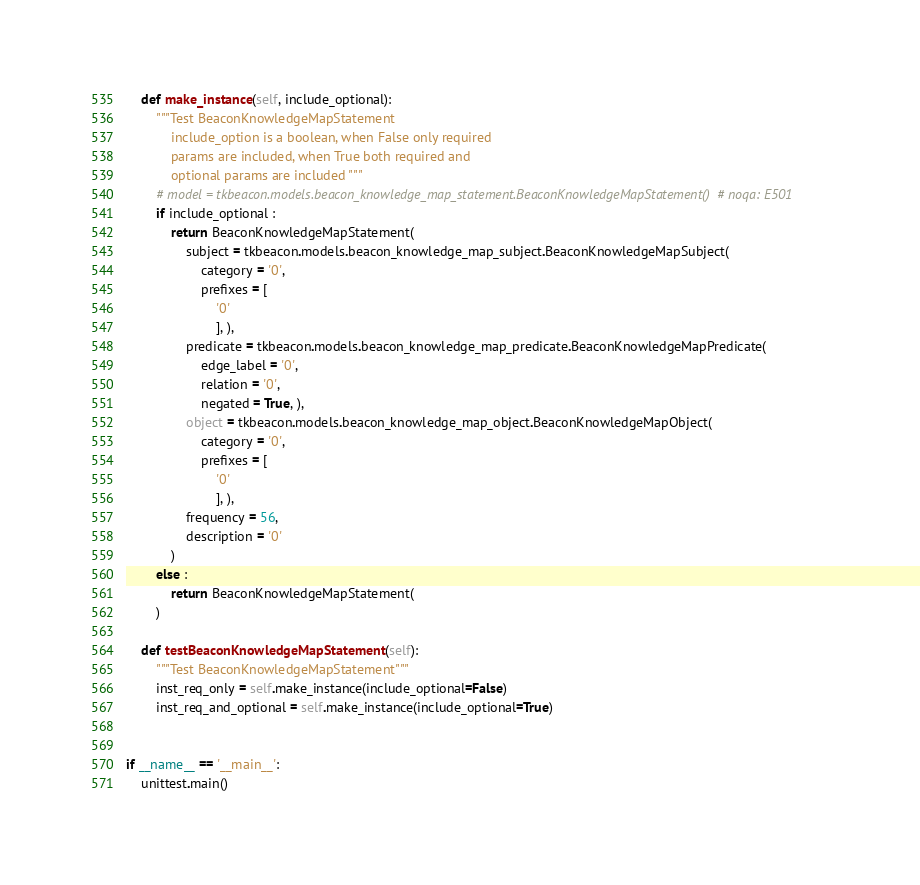<code> <loc_0><loc_0><loc_500><loc_500><_Python_>    def make_instance(self, include_optional):
        """Test BeaconKnowledgeMapStatement
            include_option is a boolean, when False only required
            params are included, when True both required and
            optional params are included """
        # model = tkbeacon.models.beacon_knowledge_map_statement.BeaconKnowledgeMapStatement()  # noqa: E501
        if include_optional :
            return BeaconKnowledgeMapStatement(
                subject = tkbeacon.models.beacon_knowledge_map_subject.BeaconKnowledgeMapSubject(
                    category = '0', 
                    prefixes = [
                        '0'
                        ], ), 
                predicate = tkbeacon.models.beacon_knowledge_map_predicate.BeaconKnowledgeMapPredicate(
                    edge_label = '0', 
                    relation = '0', 
                    negated = True, ), 
                object = tkbeacon.models.beacon_knowledge_map_object.BeaconKnowledgeMapObject(
                    category = '0', 
                    prefixes = [
                        '0'
                        ], ), 
                frequency = 56, 
                description = '0'
            )
        else :
            return BeaconKnowledgeMapStatement(
        )

    def testBeaconKnowledgeMapStatement(self):
        """Test BeaconKnowledgeMapStatement"""
        inst_req_only = self.make_instance(include_optional=False)
        inst_req_and_optional = self.make_instance(include_optional=True)


if __name__ == '__main__':
    unittest.main()
</code> 